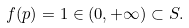Convert formula to latex. <formula><loc_0><loc_0><loc_500><loc_500>f ( p ) = 1 \in ( 0 , + \infty ) \subset S .</formula> 